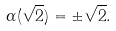<formula> <loc_0><loc_0><loc_500><loc_500>\alpha ( \sqrt { 2 } ) = \pm \sqrt { 2 } .</formula> 